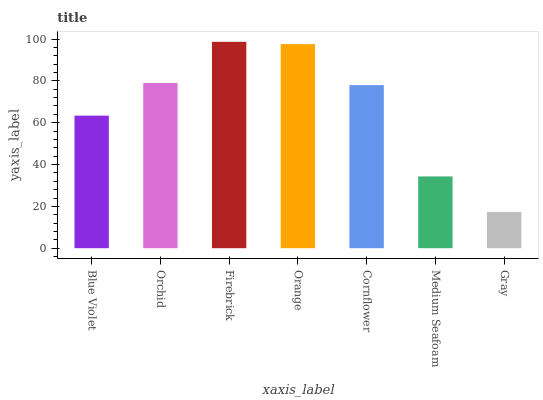Is Gray the minimum?
Answer yes or no. Yes. Is Firebrick the maximum?
Answer yes or no. Yes. Is Orchid the minimum?
Answer yes or no. No. Is Orchid the maximum?
Answer yes or no. No. Is Orchid greater than Blue Violet?
Answer yes or no. Yes. Is Blue Violet less than Orchid?
Answer yes or no. Yes. Is Blue Violet greater than Orchid?
Answer yes or no. No. Is Orchid less than Blue Violet?
Answer yes or no. No. Is Cornflower the high median?
Answer yes or no. Yes. Is Cornflower the low median?
Answer yes or no. Yes. Is Gray the high median?
Answer yes or no. No. Is Firebrick the low median?
Answer yes or no. No. 